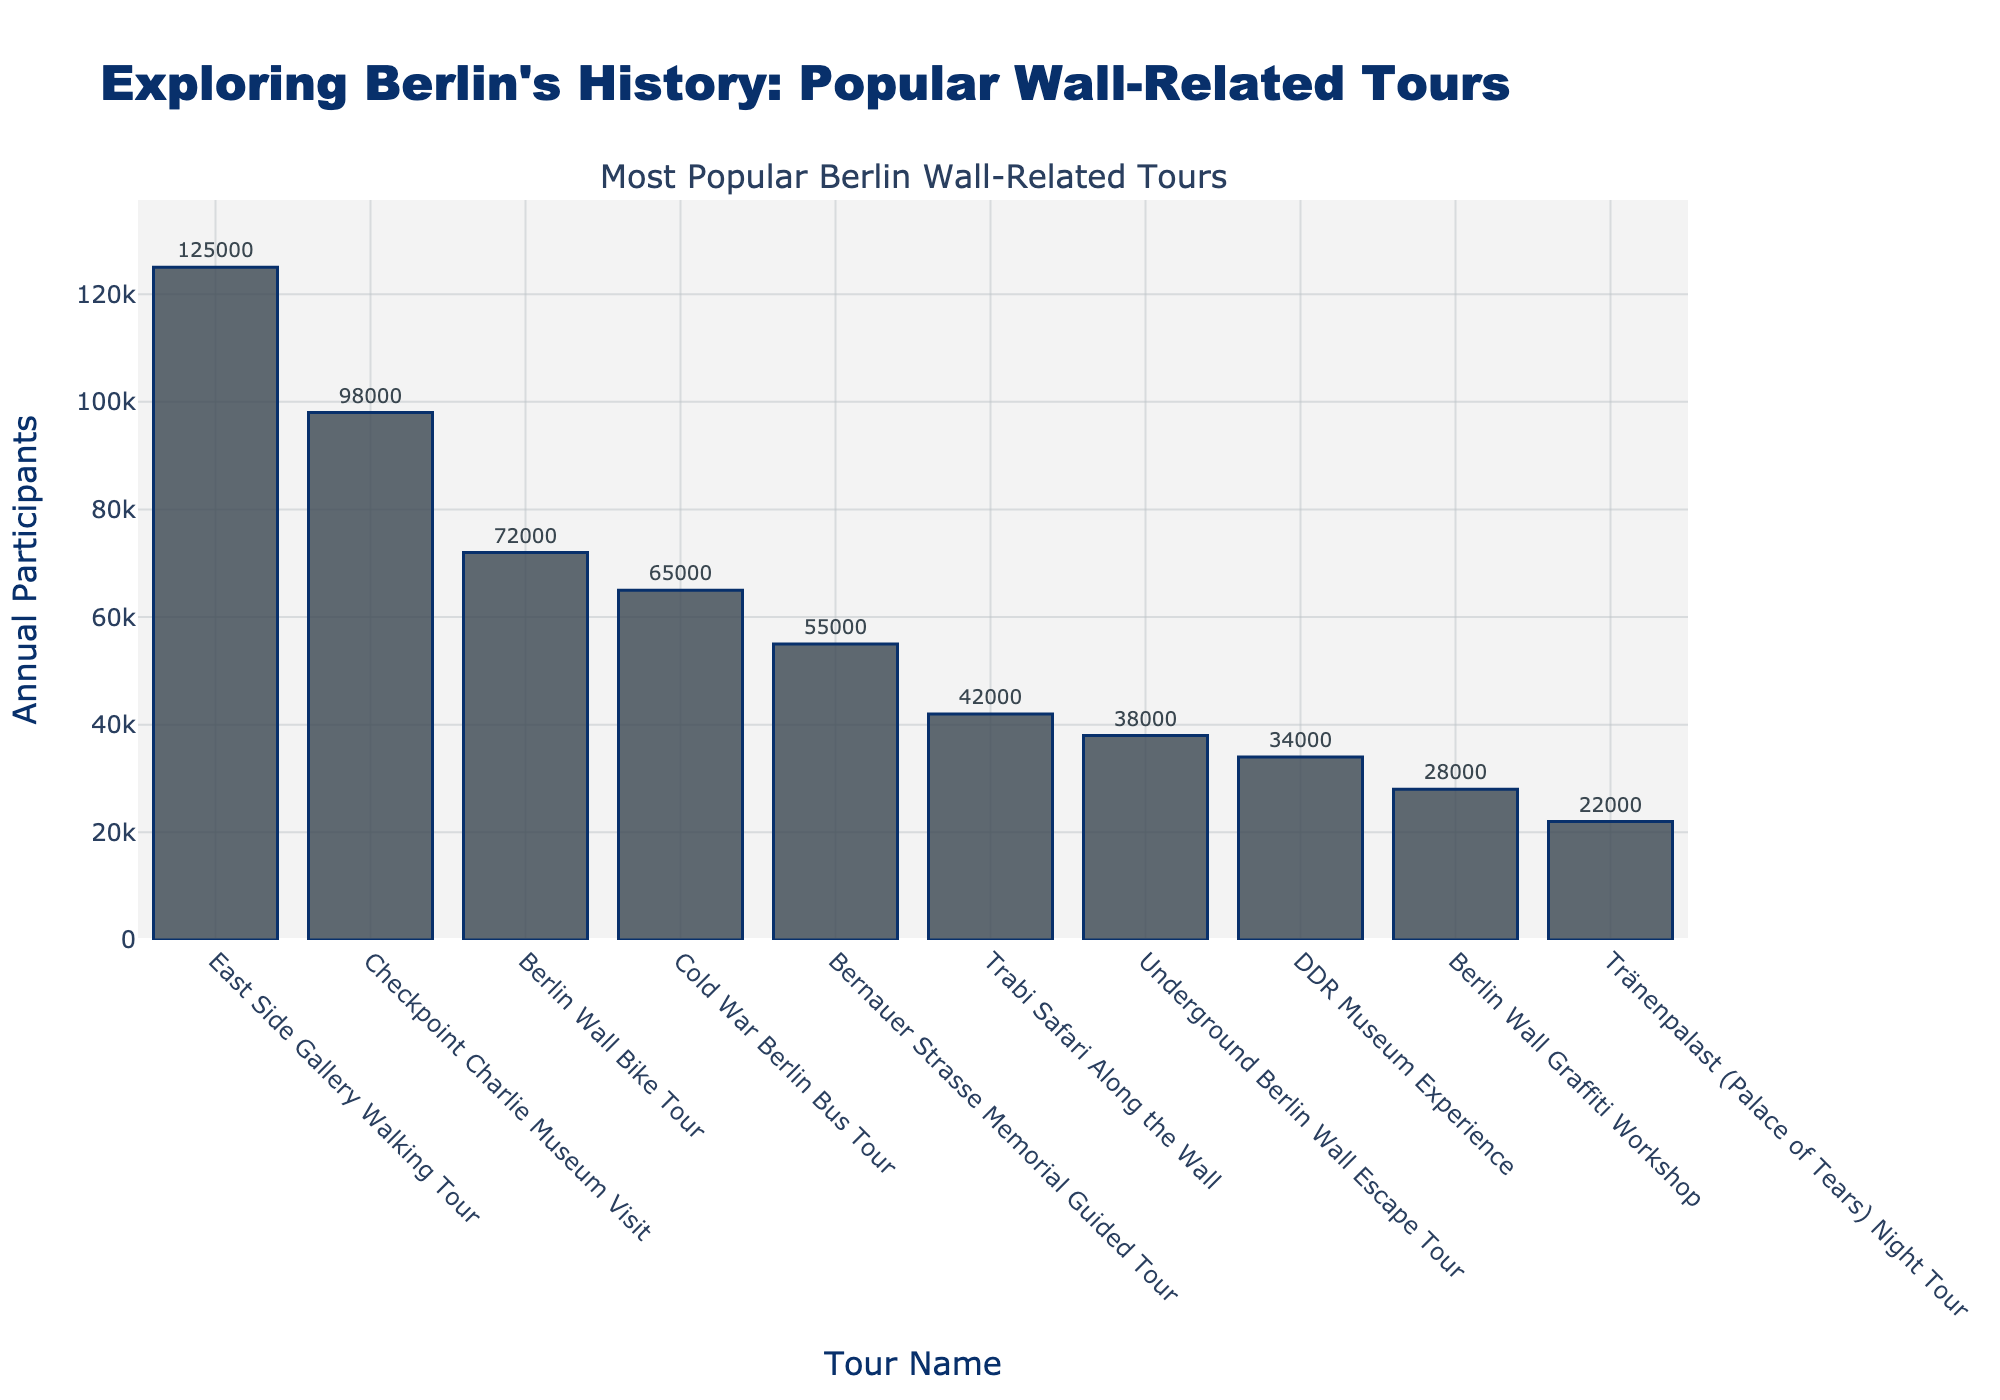Which tour has the highest number of annual participants? The "East Side Gallery Walking Tour" is at the top of the bar chart, indicating it has the highest number of annual participants. It has 125,000 participants annually.
Answer: East Side Gallery Walking Tour What is the combined number of annual participants for the "Berlin Wall Bike Tour" and the "Cold War Berlin Bus Tour"? Add the annual participants of the "Berlin Wall Bike Tour" (72,000) and the "Cold War Berlin Bus Tour" (65,000): 72,000 + 65,000 = 137,000.
Answer: 137,000 How many more participants does the "East Side Gallery Walking Tour" have compared to the "Checkpoint Charlie Museum Visit"? Subtract the annual participants of the "Checkpoint Charlie Museum Visit" (98,000) from the "East Side Gallery Walking Tour" (125,000): 125,000 - 98,000 = 27,000.
Answer: 27,000 Which tour has fewer annual participants: the "DDR Museum Experience" or the "Tränenpalast (Palace of Tears) Night Tour"? Compare the annual participants of the "DDR Museum Experience" (34,000) with the "Tränenpalast (Palace of Tears) Night Tour" (22,000). The "Tränenpalast (Palace of Tears) Night Tour" has fewer participants.
Answer: Tränenpalast (Palace of Tears) Night Tour What is the average annual participation of the tours listed in the data? To find the average, sum up the annual participants for all tours and divide by the number of tours: (125,000 + 98,000 + 72,000 + 65,000 + 55,000 + 42,000 + 38,000 + 34,000 + 28,000 + 22,000) = 579,000. There are 10 tours listed, so 579,000 / 10 = 57,900 participants on average.
Answer: 57,900 How does the participation in the "Underground Berlin Wall Escape Tour" compare to the "Trabi Safari Along the Wall"? The "Underground Berlin Wall Escape Tour" has 38,000 participants, while the "Trabi Safari Along the Wall" has 42,000. The latter has 4,000 more participants (42,000 - 38,000 = 4,000).
Answer: The Trabi Safari Along the Wall has 4,000 more participants If you combine the participants of the least popular three tours, what is the total? Add the participants of the least popular three tours: "Berlin Wall Graffiti Workshop" (28,000), "Tränenpalast (Palace of Tears) Night Tour" (22,000), and "DDR Museum Experience" (34,000): 28,000 + 22,000 + 34,000 = 84,000.
Answer: 84,000 Which tour has closer participation to the midpoint of the range of participants shown in the chart? First, identify the range: 125,000 (max, East Side Gallery) - 22,000 (min, Tränenpalast Night Tour) = 103,000. The midpoint is 103,000 / 2 = 51,500. "Bernauer Strasse Memorial Guided Tour" has 55,000, closest to 51,500.
Answer: Bernauer Strasse Memorial Guided Tour 